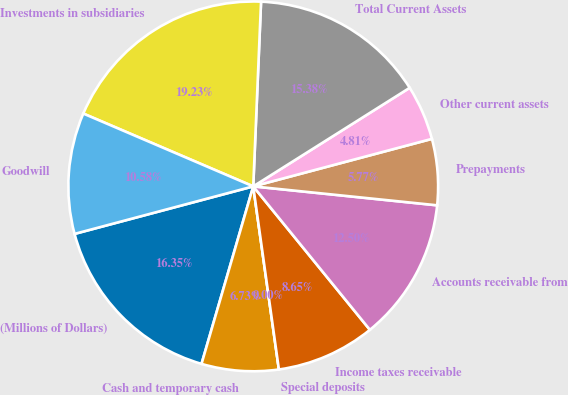<chart> <loc_0><loc_0><loc_500><loc_500><pie_chart><fcel>(Millions of Dollars)<fcel>Cash and temporary cash<fcel>Special deposits<fcel>Income taxes receivable<fcel>Accounts receivable from<fcel>Prepayments<fcel>Other current assets<fcel>Total Current Assets<fcel>Investments in subsidiaries<fcel>Goodwill<nl><fcel>16.35%<fcel>6.73%<fcel>0.0%<fcel>8.65%<fcel>12.5%<fcel>5.77%<fcel>4.81%<fcel>15.38%<fcel>19.23%<fcel>10.58%<nl></chart> 